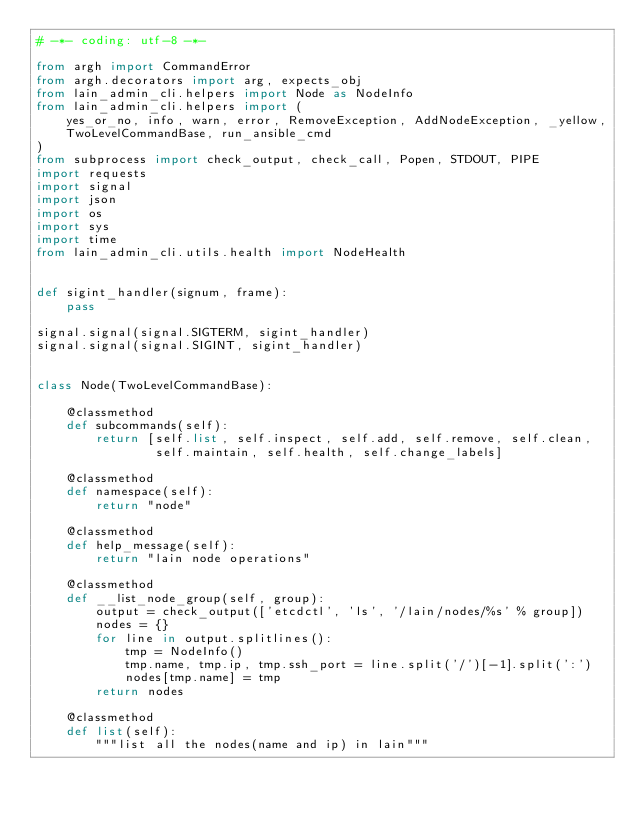<code> <loc_0><loc_0><loc_500><loc_500><_Python_># -*- coding: utf-8 -*-

from argh import CommandError
from argh.decorators import arg, expects_obj
from lain_admin_cli.helpers import Node as NodeInfo
from lain_admin_cli.helpers import (
    yes_or_no, info, warn, error, RemoveException, AddNodeException, _yellow,
    TwoLevelCommandBase, run_ansible_cmd
)
from subprocess import check_output, check_call, Popen, STDOUT, PIPE
import requests
import signal
import json
import os
import sys
import time
from lain_admin_cli.utils.health import NodeHealth


def sigint_handler(signum, frame):
    pass

signal.signal(signal.SIGTERM, sigint_handler)
signal.signal(signal.SIGINT, sigint_handler)


class Node(TwoLevelCommandBase):

    @classmethod
    def subcommands(self):
        return [self.list, self.inspect, self.add, self.remove, self.clean,
                self.maintain, self.health, self.change_labels]

    @classmethod
    def namespace(self):
        return "node"

    @classmethod
    def help_message(self):
        return "lain node operations"

    @classmethod
    def __list_node_group(self, group):
        output = check_output(['etcdctl', 'ls', '/lain/nodes/%s' % group])
        nodes = {}
        for line in output.splitlines():
            tmp = NodeInfo()
            tmp.name, tmp.ip, tmp.ssh_port = line.split('/')[-1].split(':')
            nodes[tmp.name] = tmp
        return nodes

    @classmethod
    def list(self):
        """list all the nodes(name and ip) in lain"""</code> 